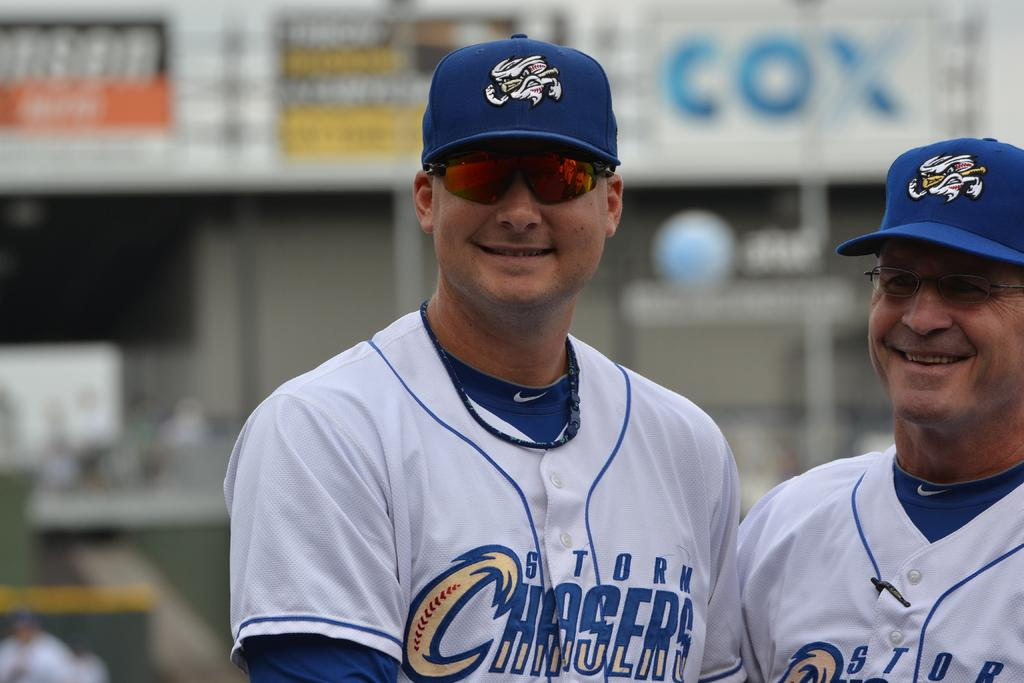Provide a one-sentence caption for the provided image. Baseball player with sunglasses on and Storm Chasers on his uniform. 